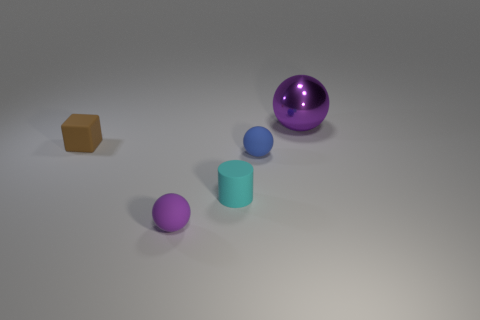Subtract all purple metal balls. How many balls are left? 2 Add 4 rubber blocks. How many objects exist? 9 Subtract all spheres. How many objects are left? 2 Add 3 small cyan shiny cylinders. How many small cyan shiny cylinders exist? 3 Subtract all blue spheres. How many spheres are left? 2 Subtract 0 purple cubes. How many objects are left? 5 Subtract all yellow cylinders. Subtract all red spheres. How many cylinders are left? 1 Subtract all blue blocks. How many red cylinders are left? 0 Subtract all yellow cylinders. Subtract all small rubber balls. How many objects are left? 3 Add 5 small cubes. How many small cubes are left? 6 